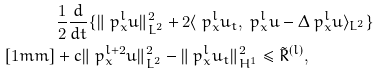<formula> <loc_0><loc_0><loc_500><loc_500>& \frac { 1 } { 2 } \frac { d } { d t } \{ \| \ p ^ { l } _ { x } u \| ^ { 2 } _ { L ^ { 2 } } + 2 \langle \ p ^ { l } _ { x } u _ { t } , \ p ^ { l } _ { x } u - \Delta \ p ^ { l } _ { x } u \rangle _ { L ^ { 2 } } \} \\ [ 1 m m ] & + c \| \ p ^ { l + 2 } _ { x } u \| ^ { 2 } _ { L ^ { 2 } } - \| \ p ^ { l } _ { x } u _ { t } \| _ { H ^ { 1 } } ^ { 2 } \leq \tilde { R } ^ { ( l ) } ,</formula> 